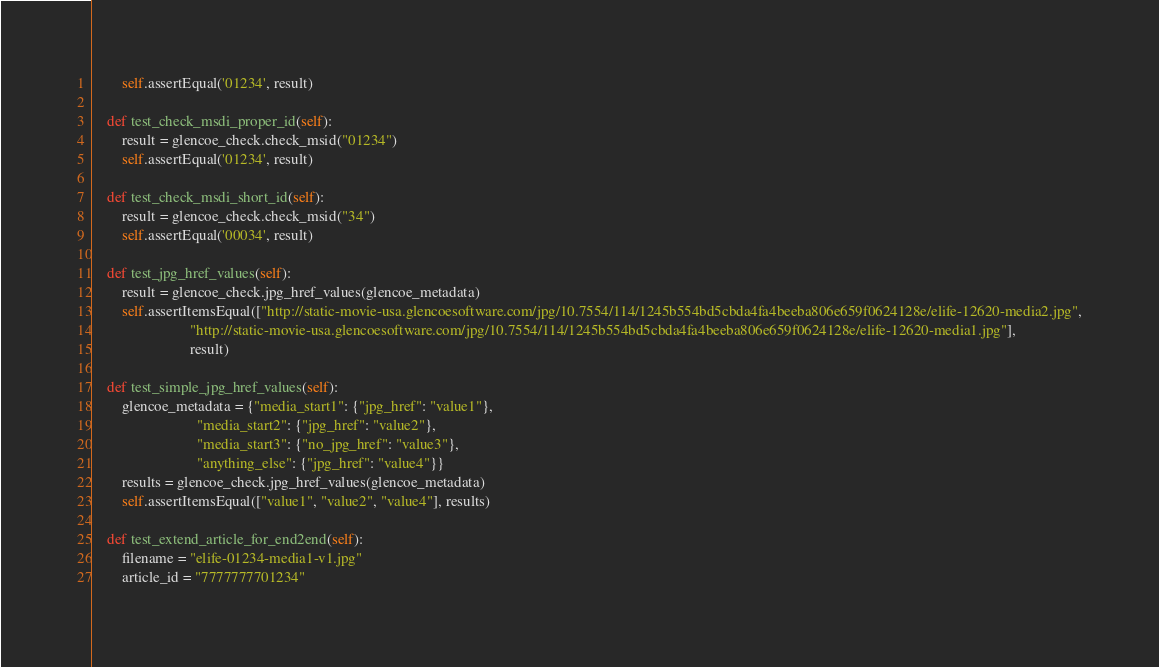<code> <loc_0><loc_0><loc_500><loc_500><_Python_>        self.assertEqual('01234', result)

    def test_check_msdi_proper_id(self):
        result = glencoe_check.check_msid("01234")
        self.assertEqual('01234', result)

    def test_check_msdi_short_id(self):
        result = glencoe_check.check_msid("34")
        self.assertEqual('00034', result)

    def test_jpg_href_values(self):
        result = glencoe_check.jpg_href_values(glencoe_metadata)
        self.assertItemsEqual(["http://static-movie-usa.glencoesoftware.com/jpg/10.7554/114/1245b554bd5cbda4fa4beeba806e659f0624128e/elife-12620-media2.jpg",
                          "http://static-movie-usa.glencoesoftware.com/jpg/10.7554/114/1245b554bd5cbda4fa4beeba806e659f0624128e/elife-12620-media1.jpg"],
                          result)

    def test_simple_jpg_href_values(self):
        glencoe_metadata = {"media_start1": {"jpg_href": "value1"},
                            "media_start2": {"jpg_href": "value2"},
                            "media_start3": {"no_jpg_href": "value3"},
                            "anything_else": {"jpg_href": "value4"}}
        results = glencoe_check.jpg_href_values(glencoe_metadata)
        self.assertItemsEqual(["value1", "value2", "value4"], results)

    def test_extend_article_for_end2end(self):
        filename = "elife-01234-media1-v1.jpg"
        article_id = "7777777701234"</code> 